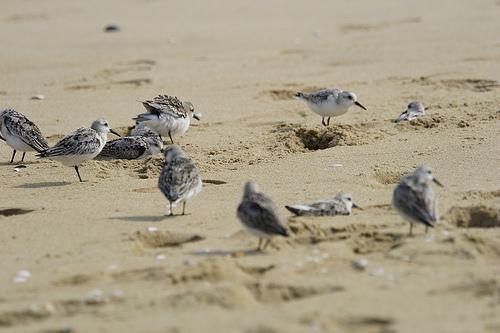How many people are in this photo?
Give a very brief answer. 0. 